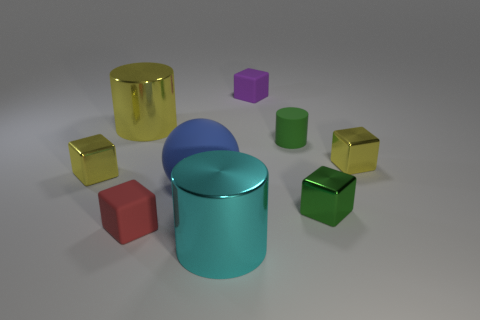There is a purple cube that is the same size as the red object; what material is it?
Give a very brief answer. Rubber. What number of objects are either matte objects that are left of the purple thing or yellow shiny things that are in front of the yellow shiny cylinder?
Provide a short and direct response. 4. What size is the cyan object that is made of the same material as the large yellow thing?
Offer a terse response. Large. What number of rubber objects are purple cylinders or tiny cylinders?
Keep it short and to the point. 1. What size is the green cylinder?
Give a very brief answer. Small. Do the red rubber block and the blue object have the same size?
Provide a short and direct response. No. What material is the purple block to the right of the big cyan cylinder?
Your answer should be compact. Rubber. What material is the green thing that is the same shape as the red object?
Provide a succinct answer. Metal. Is there a tiny yellow cube that is in front of the tiny yellow metallic thing that is to the right of the matte cylinder?
Your response must be concise. Yes. Does the green shiny thing have the same shape as the red object?
Give a very brief answer. Yes. 